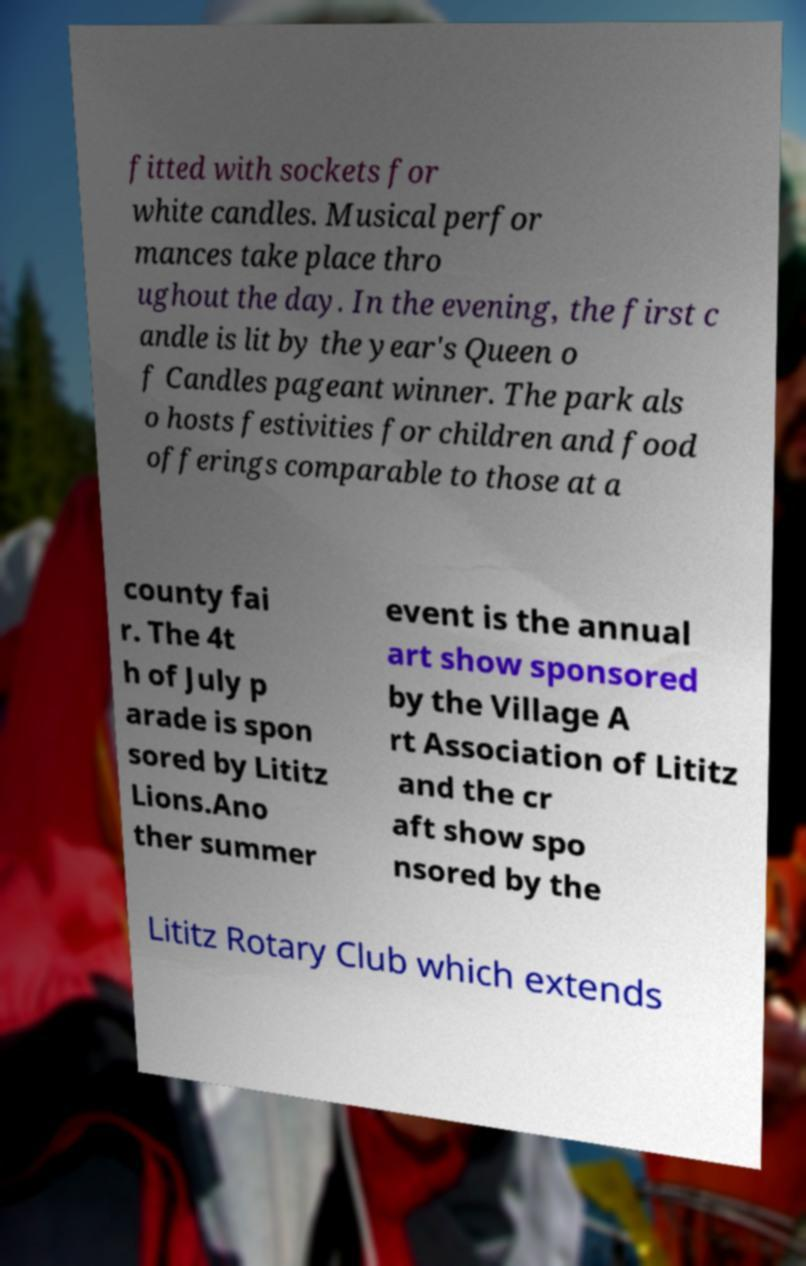Please identify and transcribe the text found in this image. fitted with sockets for white candles. Musical perfor mances take place thro ughout the day. In the evening, the first c andle is lit by the year's Queen o f Candles pageant winner. The park als o hosts festivities for children and food offerings comparable to those at a county fai r. The 4t h of July p arade is spon sored by Lititz Lions.Ano ther summer event is the annual art show sponsored by the Village A rt Association of Lititz and the cr aft show spo nsored by the Lititz Rotary Club which extends 